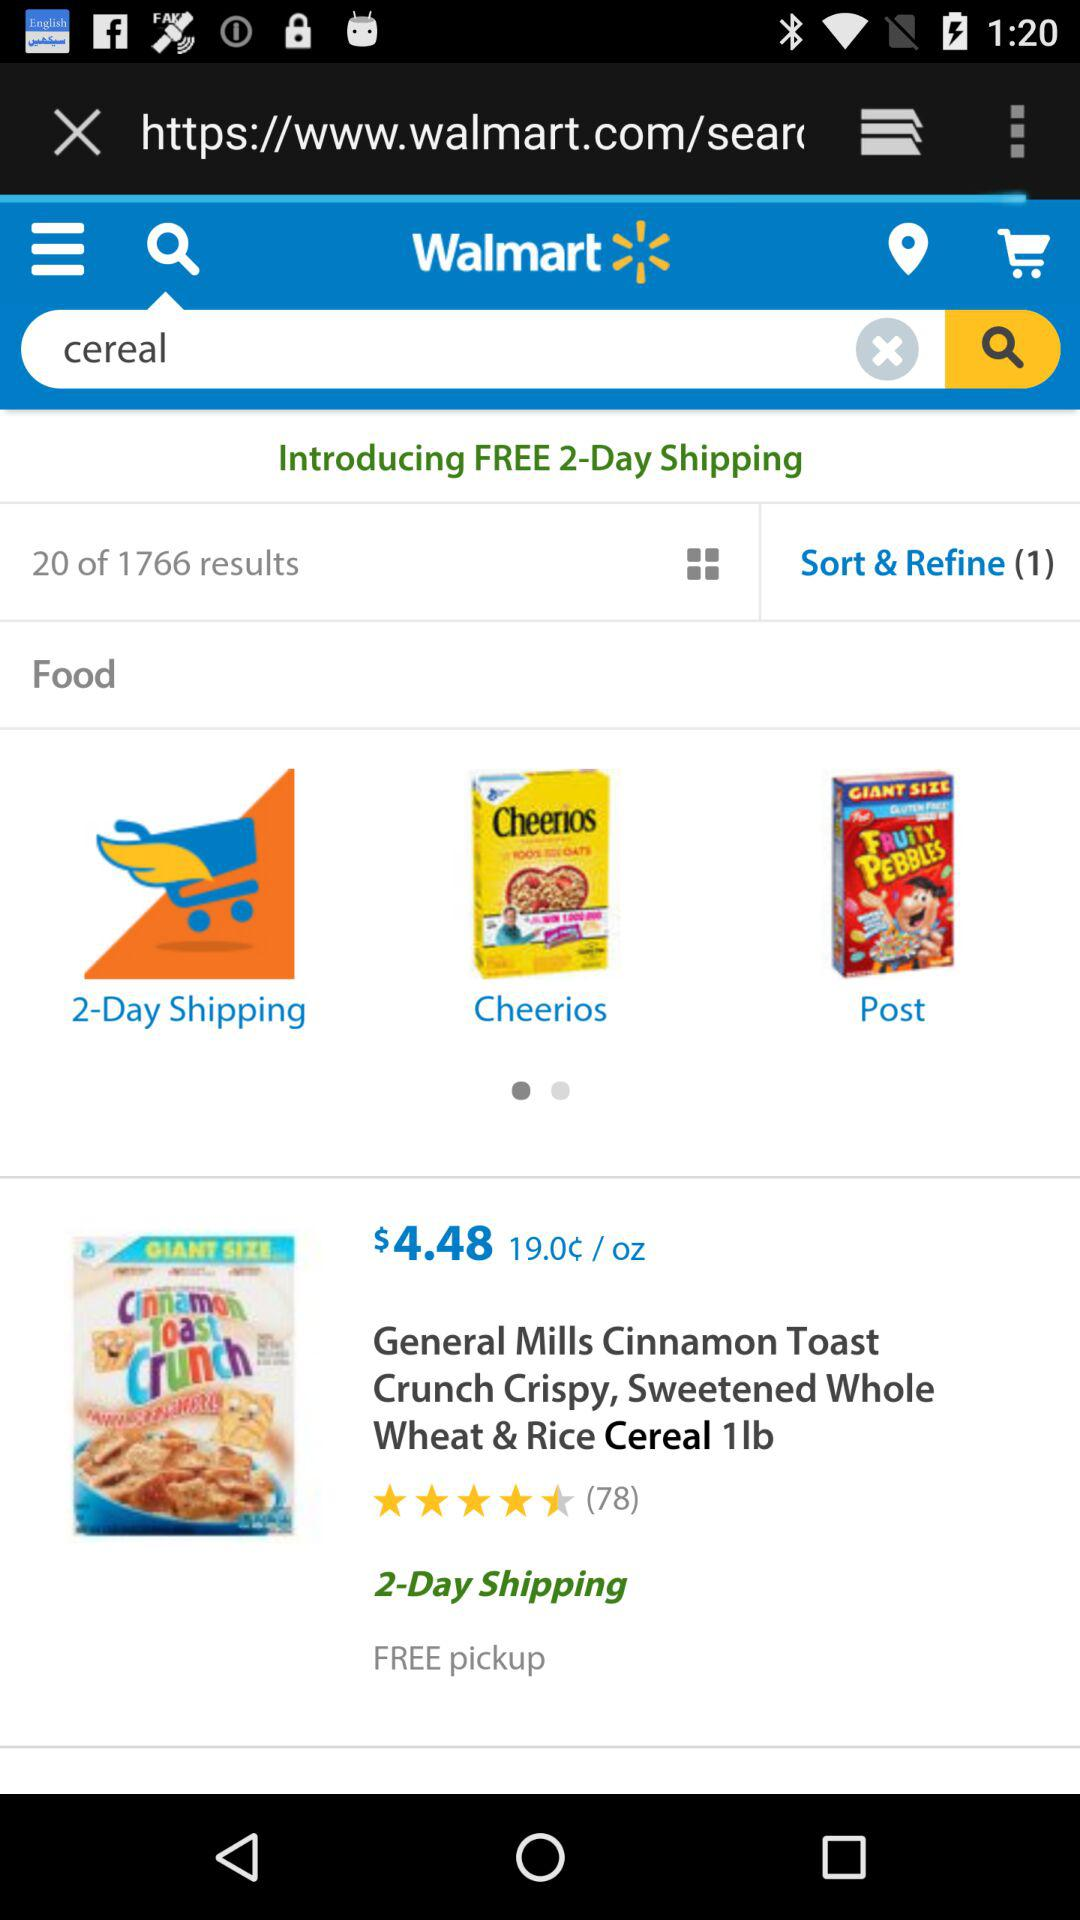What is the number of the rating stars? The number is 4.5. 